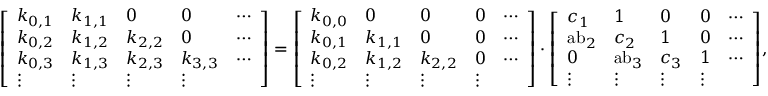Convert formula to latex. <formula><loc_0><loc_0><loc_500><loc_500>{ \left [ \begin{array} { l l l l l } { k _ { 0 , 1 } } & { k _ { 1 , 1 } } & { 0 } & { 0 } & { \cdots } \\ { k _ { 0 , 2 } } & { k _ { 1 , 2 } } & { k _ { 2 , 2 } } & { 0 } & { \cdots } \\ { k _ { 0 , 3 } } & { k _ { 1 , 3 } } & { k _ { 2 , 3 } } & { k _ { 3 , 3 } } & { \cdots } \\ { \vdots } & { \vdots } & { \vdots } & { \vdots } \end{array} \right ] } = { \left [ \begin{array} { l l l l l } { k _ { 0 , 0 } } & { 0 } & { 0 } & { 0 } & { \cdots } \\ { k _ { 0 , 1 } } & { k _ { 1 , 1 } } & { 0 } & { 0 } & { \cdots } \\ { k _ { 0 , 2 } } & { k _ { 1 , 2 } } & { k _ { 2 , 2 } } & { 0 } & { \cdots } \\ { \vdots } & { \vdots } & { \vdots } & { \vdots } \end{array} \right ] } \cdot { \left [ \begin{array} { l l l l l } { c _ { 1 } } & { 1 } & { 0 } & { 0 } & { \cdots } \\ { { a b } _ { 2 } } & { c _ { 2 } } & { 1 } & { 0 } & { \cdots } \\ { 0 } & { { a b } _ { 3 } } & { c _ { 3 } } & { 1 } & { \cdots } \\ { \vdots } & { \vdots } & { \vdots } & { \vdots } \end{array} \right ] } ,</formula> 